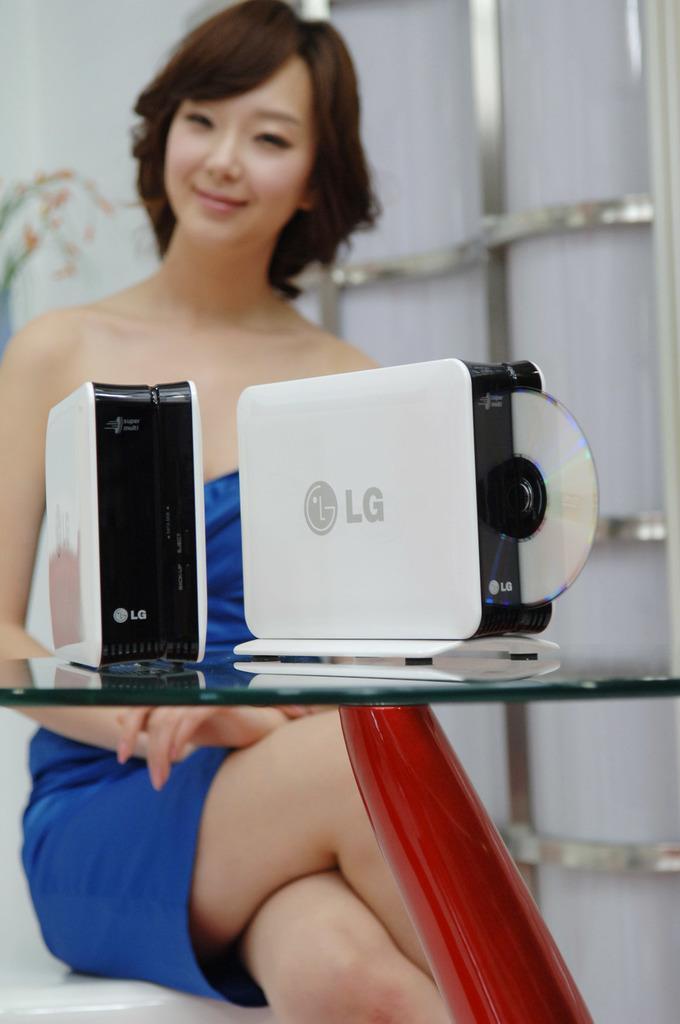Could you give a brief overview of what you see in this image? In this picture we can observe a woman sitting on the white color stool. She is wearing blue color dress. The woman is smiling. In front of her we can observe a glass table on which two devices are placed which are in white color. The background is blurred. 